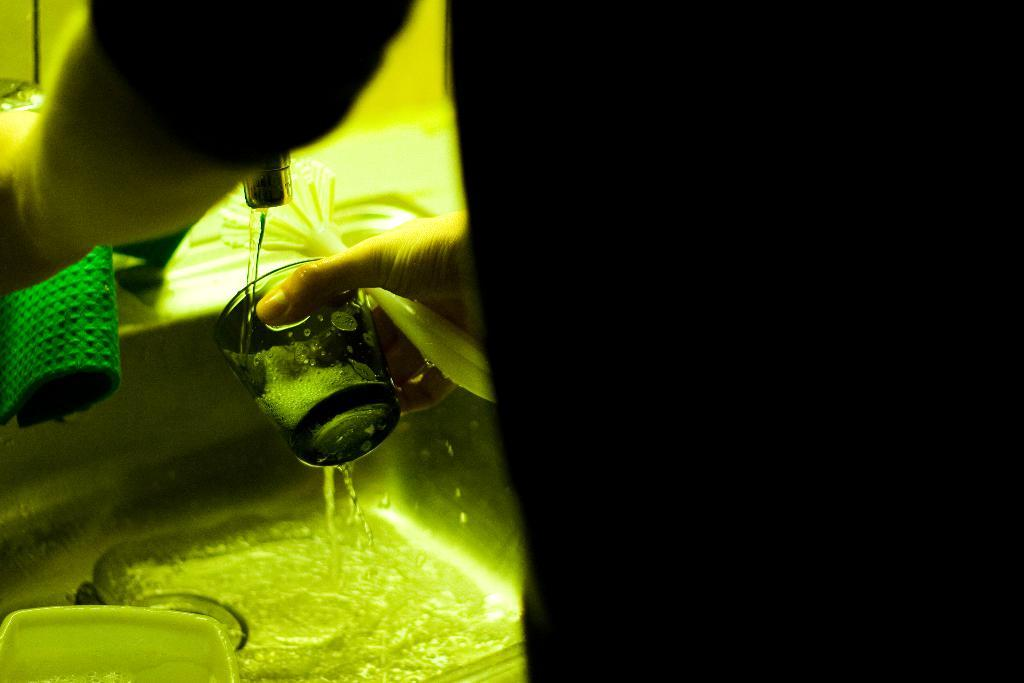Who is present in the image? There is a person in the image. What is the person doing in the image? The person is standing in front of a sink and washing a glass with water. What can be seen near the sink in the image? There is a tap in the image. What other object is present in the sink? There is a white color bowl in the sink. What type of mark can be seen on the side of the glass being washed? There is no mention of a mark on the glass in the image, so we cannot determine if there is one or not. 